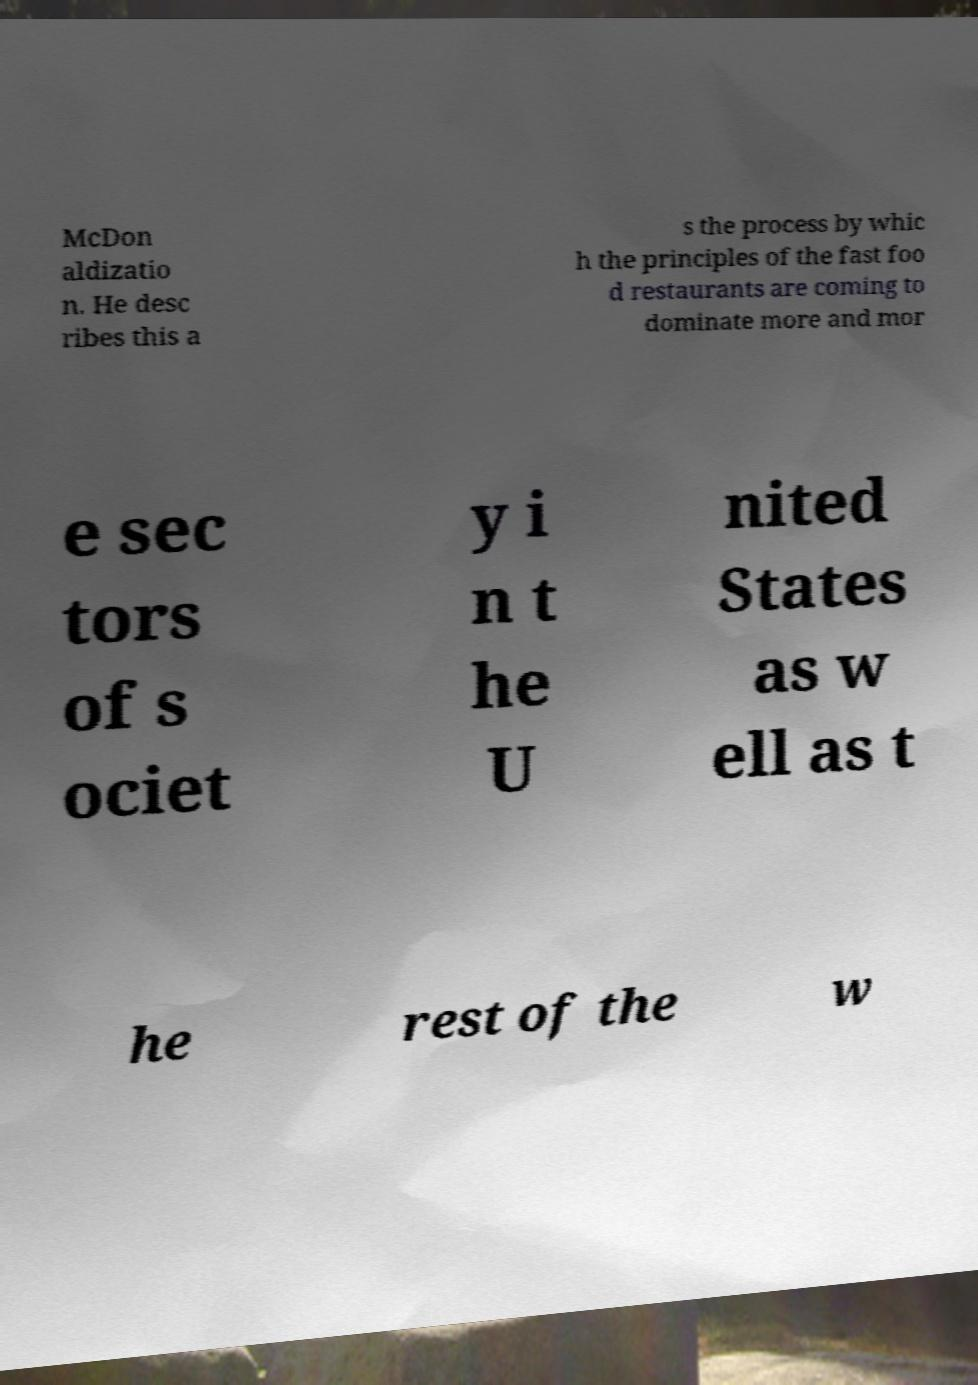Could you assist in decoding the text presented in this image and type it out clearly? McDon aldizatio n. He desc ribes this a s the process by whic h the principles of the fast foo d restaurants are coming to dominate more and mor e sec tors of s ociet y i n t he U nited States as w ell as t he rest of the w 